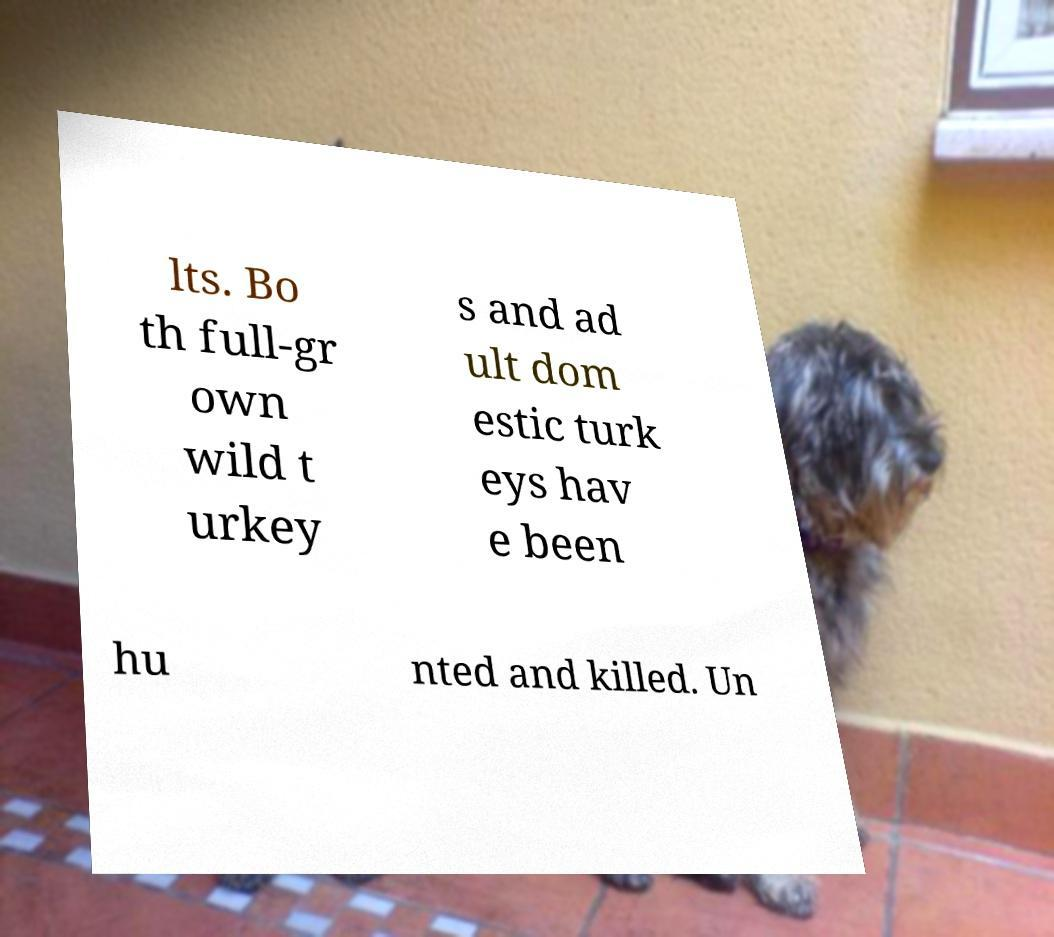Please read and relay the text visible in this image. What does it say? lts. Bo th full-gr own wild t urkey s and ad ult dom estic turk eys hav e been hu nted and killed. Un 